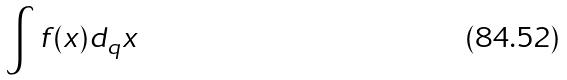<formula> <loc_0><loc_0><loc_500><loc_500>\int f ( x ) d _ { q } x</formula> 